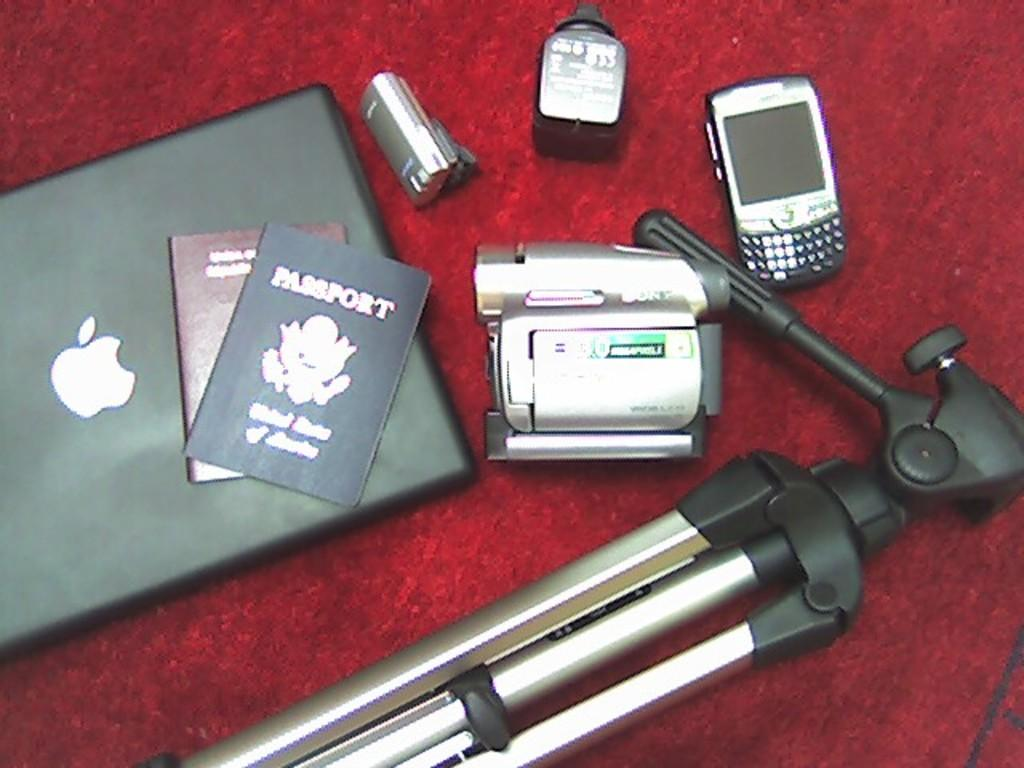<image>
Render a clear and concise summary of the photo. A passport lies on top of a laptop computer amid other tech equipment. 